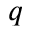Convert formula to latex. <formula><loc_0><loc_0><loc_500><loc_500>q</formula> 